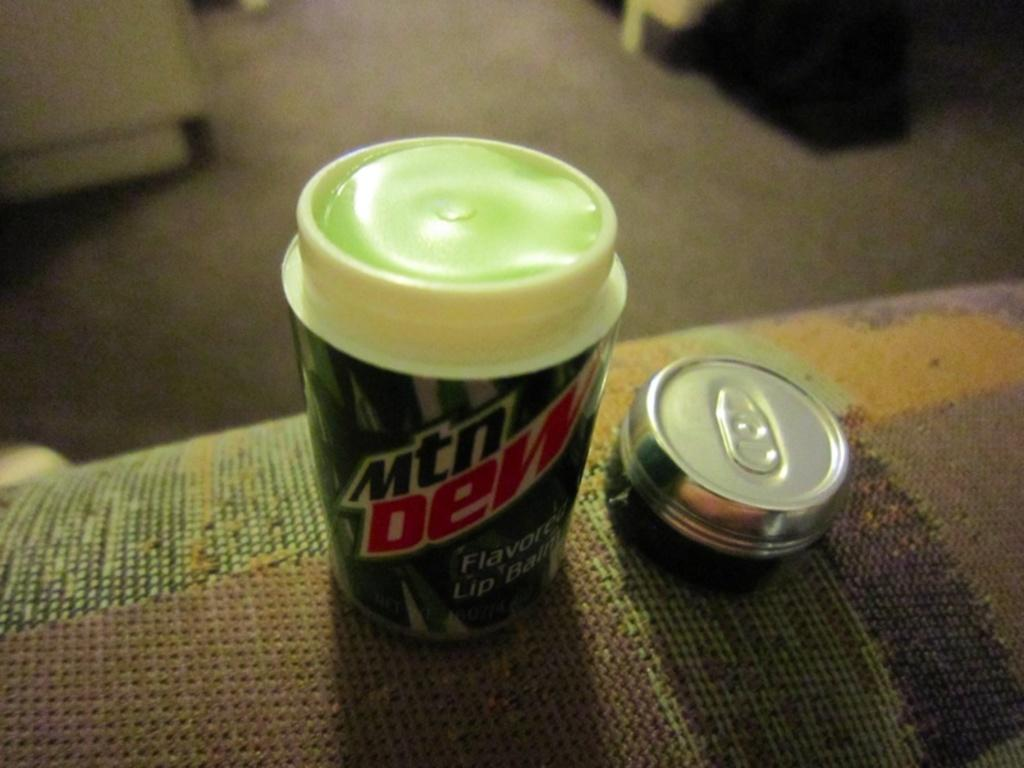<image>
Give a short and clear explanation of the subsequent image. Flavored Lip balm looks like a Mtn Dew can. 